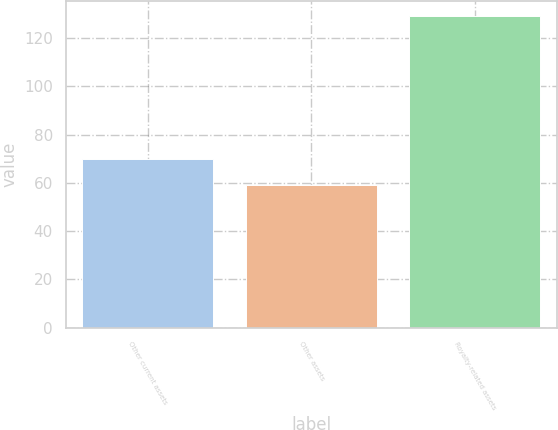Convert chart to OTSL. <chart><loc_0><loc_0><loc_500><loc_500><bar_chart><fcel>Other current assets<fcel>Other assets<fcel>Royalty-related assets<nl><fcel>70<fcel>59<fcel>129<nl></chart> 